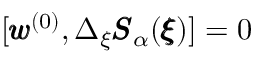<formula> <loc_0><loc_0><loc_500><loc_500>[ { \pm b w } ^ { ( 0 ) } , \Delta _ { \xi } { \pm b S } _ { \alpha } ( { \pm b \xi } ) ] = 0</formula> 